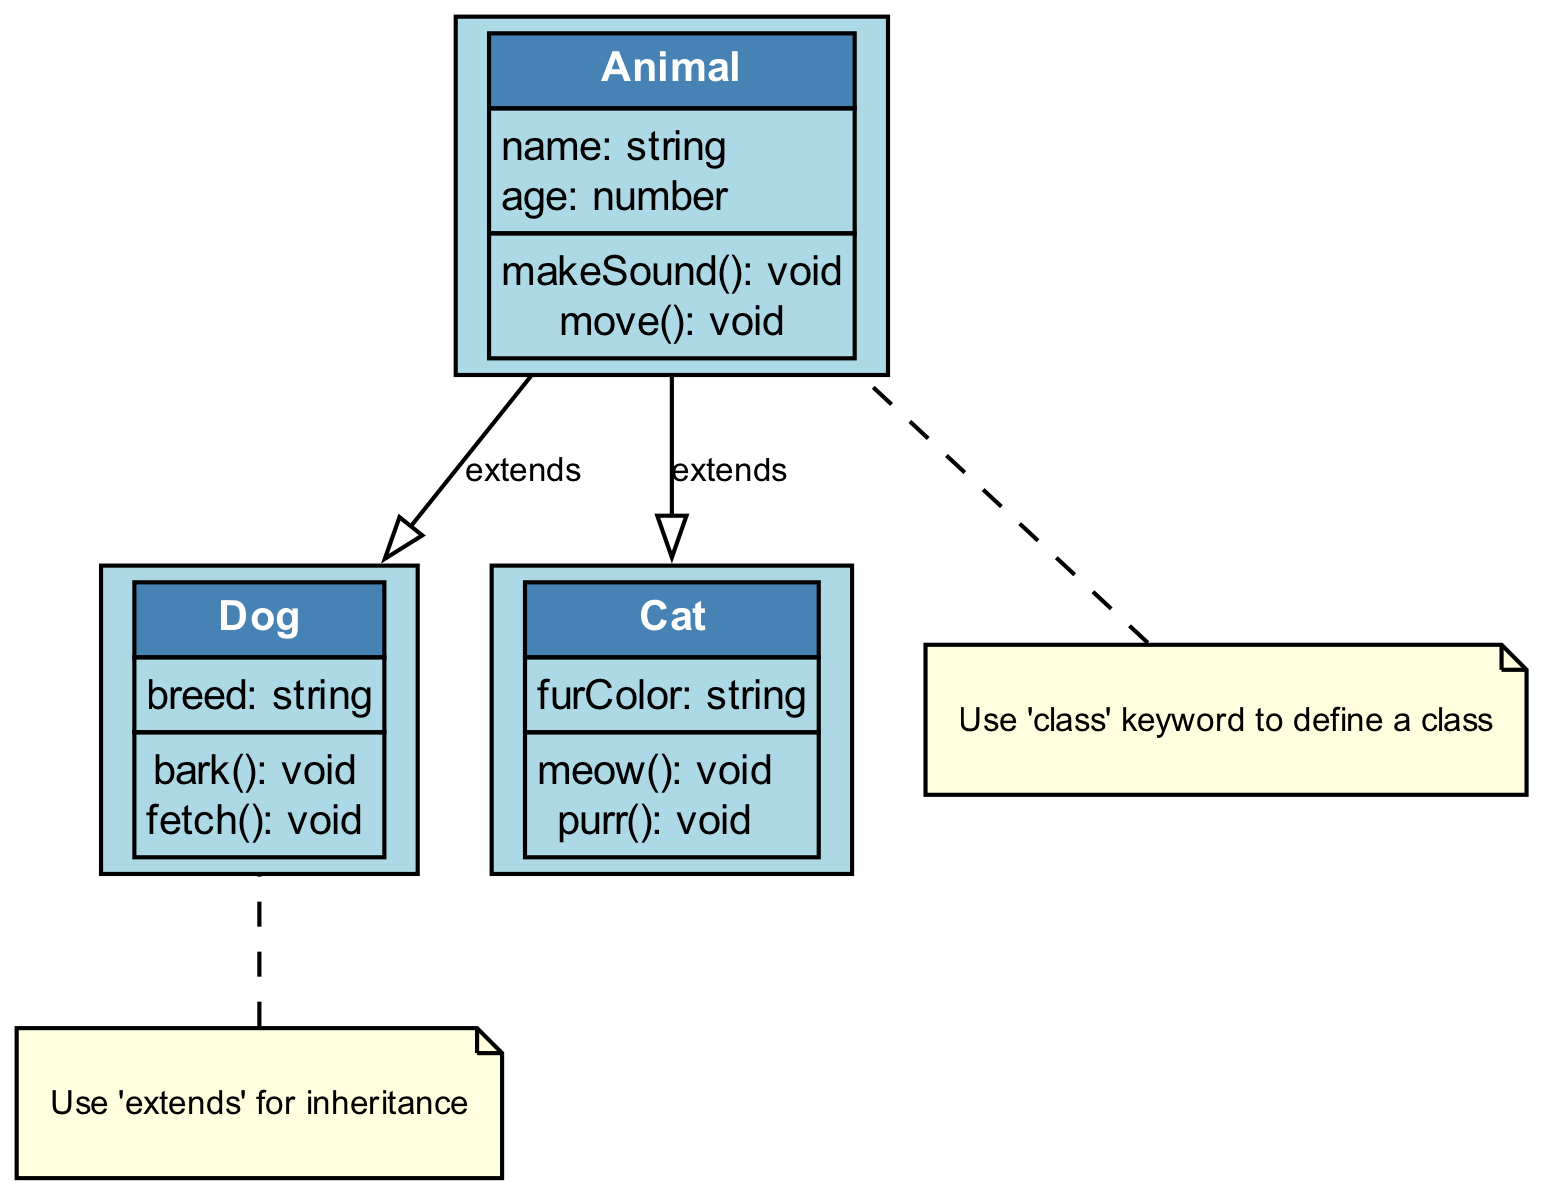What is the superclass of Dog? The diagram shows that Dog extends Animal, indicating that Animal is the superclass of Dog. Therefore, we can conclude that the superclass of Dog is Animal.
Answer: Animal How many attributes does the Cat class have? In the diagram, the Cat class lists one attribute, which is "furColor: string". Thus, there is only one attribute associated with the Cat class.
Answer: 1 What method does the Animal class have? The diagram displays two methods under the Animal class: "makeSound()" and "move()". Hence, we can deduce that these are the methods defined for the Animal class.
Answer: makeSound(), move() What is the relationship type between Cat and Animal? The diagram illustrates that Cat extends Animal, which denotes that there is an inheritance relationship. Therefore, the type of relationship between Cat and Animal is inheritance.
Answer: extends How many classes are represented in the diagram? The diagram features three classes: Animal, Dog, and Cat. By counting these, we can confirm that the total number of classes represented is three.
Answer: 3 What note is connected to the Dog class? The diagram includes a note that states, "Use 'extends' for inheritance," which is connected specifically to the Dog class. This indicates that the note provides guidance relevant to Dog.
Answer: Use 'extends' for inheritance Which class has the method 'bark'? The diagram indicates that the Dog class defines a method called "bark()", meaning that it is specific to the Dog class. Thus, this method belongs to the Dog class.
Answer: Dog What is the color of the note connected to the Animal class? The note connected to Animal has a light yellow fill color as depicted in the diagram. This color is specifically used for notes associated with classes.
Answer: light yellow Which class has the attribute 'breed'? The Dog class includes an attribute called "breed: string", indicating that the breed attribute is associated with the Dog class. Hence, this attribute is specific to the Dog class.
Answer: Dog 